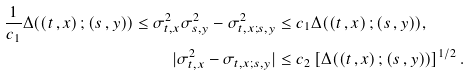Convert formula to latex. <formula><loc_0><loc_0><loc_500><loc_500>\frac { 1 } { c _ { 1 } } { \Delta } ( ( t \, , x ) \, ; ( s \, , y ) ) \leq \sigma _ { t , x } ^ { 2 } \sigma ^ { 2 } _ { s , y } - \sigma ^ { 2 } _ { t , x ; s , y } & \leq c _ { 1 } { \Delta } ( ( t \, , x ) \, ; ( s \, , y ) ) , \\ | \sigma _ { t , x } ^ { 2 } - \sigma _ { t , x ; s , y } | & \leq c _ { 2 } \left [ { \Delta } ( ( t \, , x ) \, ; ( s \, , y ) ) \right ] ^ { 1 / 2 } .</formula> 